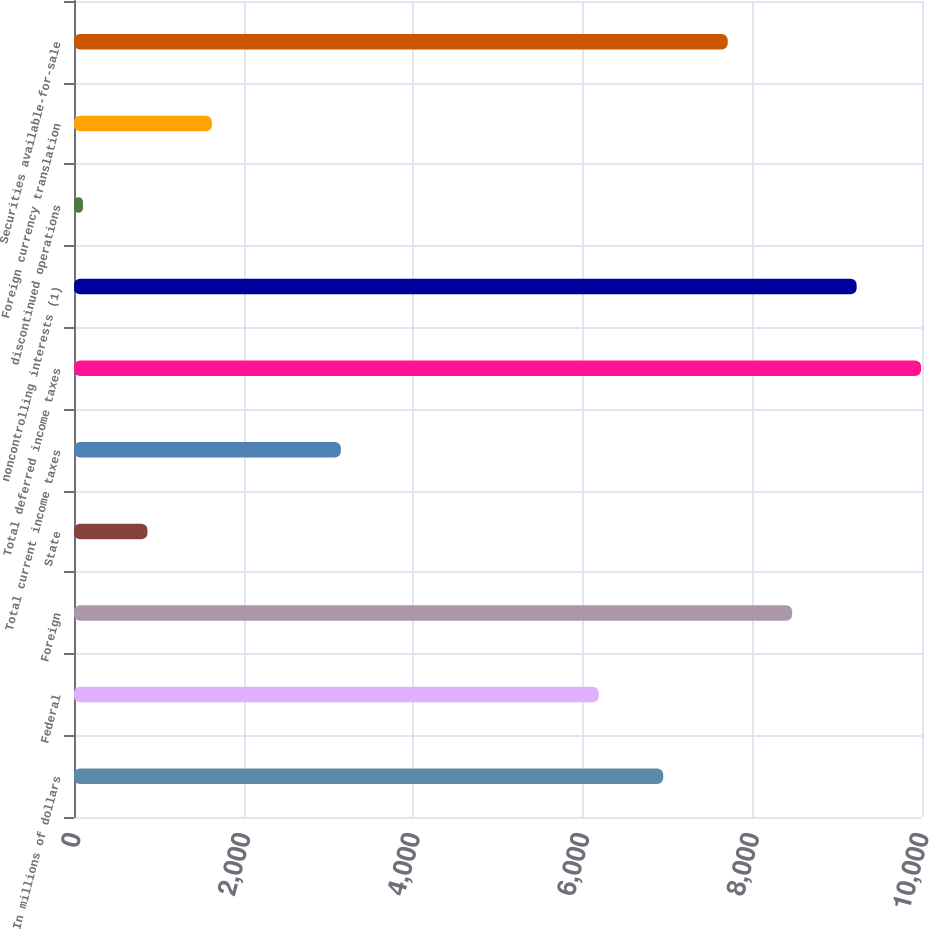Convert chart. <chart><loc_0><loc_0><loc_500><loc_500><bar_chart><fcel>In millions of dollars<fcel>Federal<fcel>Foreign<fcel>State<fcel>Total current income taxes<fcel>Total deferred income taxes<fcel>noncontrolling interests (1)<fcel>discontinued operations<fcel>Foreign currency translation<fcel>Securities available-for-sale<nl><fcel>6948.7<fcel>6188.4<fcel>8469.3<fcel>866.3<fcel>3147.2<fcel>9989.9<fcel>9229.6<fcel>106<fcel>1626.6<fcel>7709<nl></chart> 